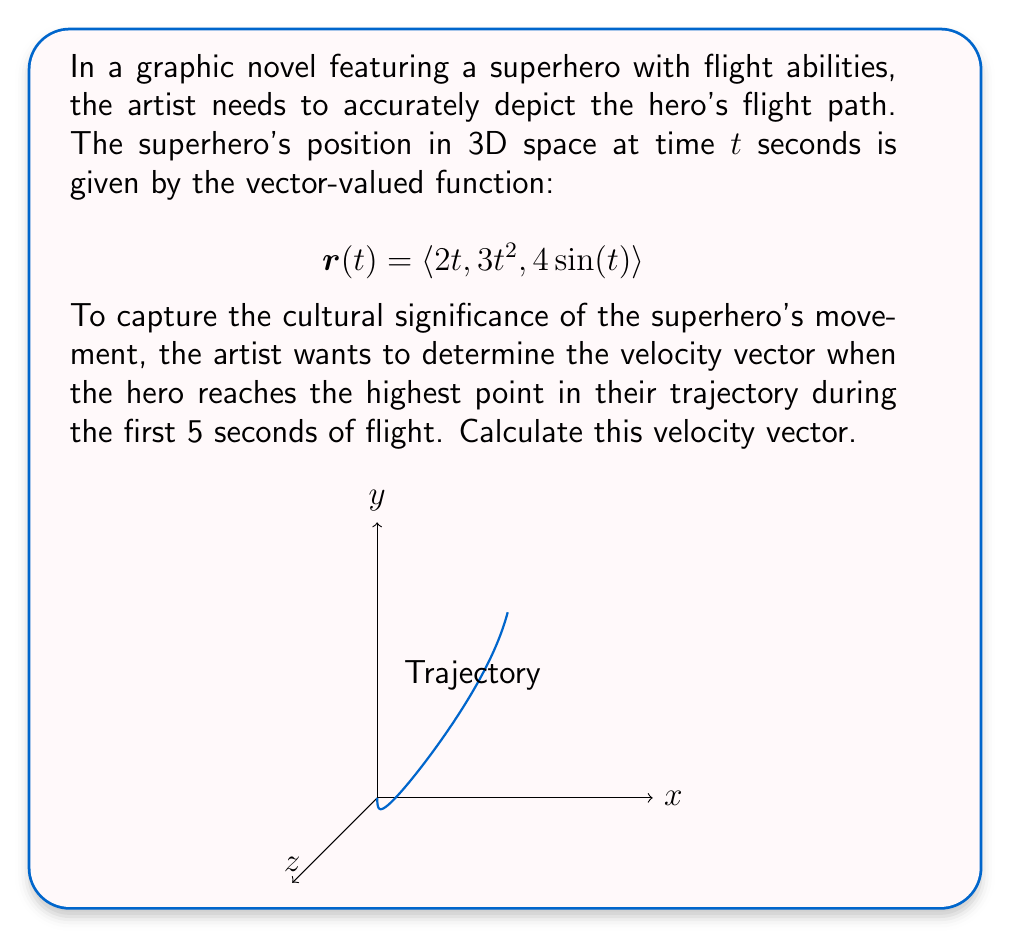Could you help me with this problem? Let's approach this step-by-step:

1) First, we need to find when the superhero reaches the highest point. This occurs when the z-component of the position vector is at its maximum.

2) The z-component is given by $z(t) = 4\sin(t)$. Its maximum value in the interval $[0,5]$ occurs when $\sin(t)$ is at its maximum, which is at $t = \pi/2 \approx 1.57$ seconds.

3) Now that we know when the highest point occurs, we need to calculate the velocity vector at this time. The velocity vector is the derivative of the position vector:

   $$\mathbf{v}(t) = \frac{d}{dt}\mathbf{r}(t) = \langle \frac{d}{dt}(2t), \frac{d}{dt}(3t^2), \frac{d}{dt}(4\sin(t)) \rangle$$

4) Calculating each component:
   
   $$\mathbf{v}(t) = \langle 2, 6t, 4\cos(t) \rangle$$

5) Now we evaluate this at $t = \pi/2$:

   $$\mathbf{v}(\pi/2) = \langle 2, 6(\pi/2), 4\cos(\pi/2) \rangle = \langle 2, 3\pi, 0 \rangle$$

Therefore, the velocity vector at the highest point of the trajectory is $\langle 2, 3\pi, 0 \rangle$.
Answer: $\langle 2, 3\pi, 0 \rangle$ 